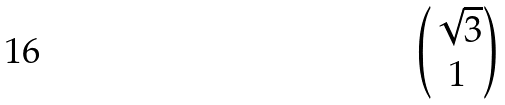<formula> <loc_0><loc_0><loc_500><loc_500>\begin{pmatrix} \sqrt { 3 } \\ 1 \end{pmatrix}</formula> 